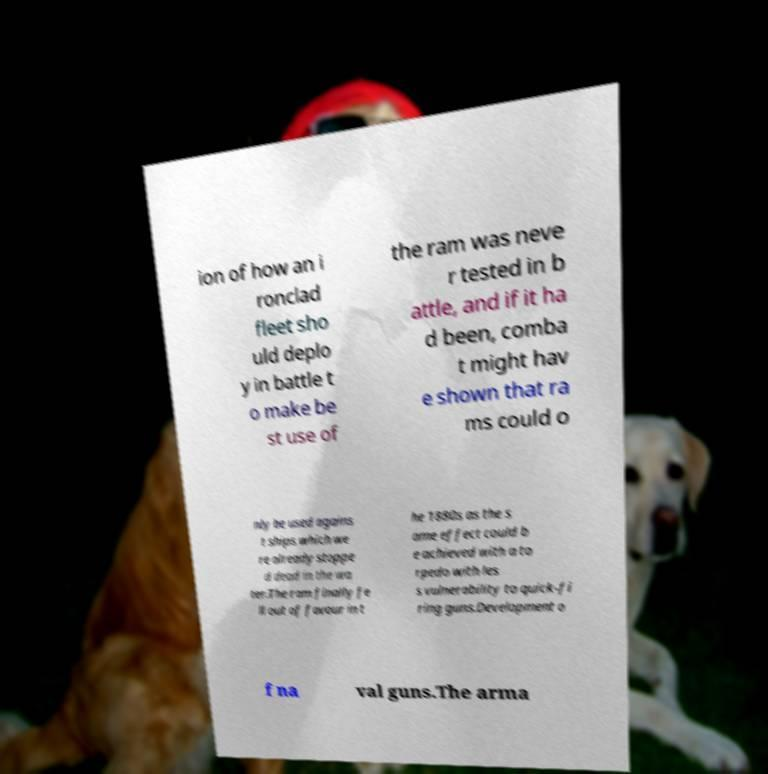Can you accurately transcribe the text from the provided image for me? ion of how an i ronclad fleet sho uld deplo y in battle t o make be st use of the ram was neve r tested in b attle, and if it ha d been, comba t might hav e shown that ra ms could o nly be used agains t ships which we re already stoppe d dead in the wa ter.The ram finally fe ll out of favour in t he 1880s as the s ame effect could b e achieved with a to rpedo with les s vulnerability to quick-fi ring guns.Development o f na val guns.The arma 